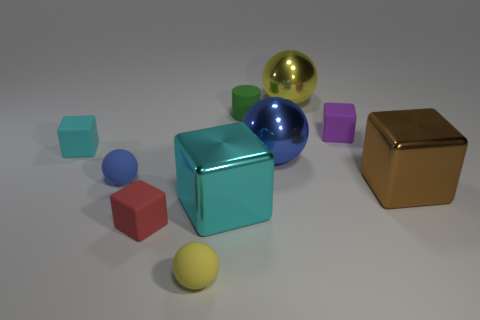Subtract all big cyan cubes. How many cubes are left? 4 Subtract 2 spheres. How many spheres are left? 2 Subtract all cyan blocks. How many blocks are left? 3 Subtract all cyan balls. Subtract all yellow cylinders. How many balls are left? 4 Subtract all blue cylinders. How many green spheres are left? 0 Subtract all big yellow metallic things. Subtract all large cyan metallic cubes. How many objects are left? 8 Add 4 tiny rubber things. How many tiny rubber things are left? 10 Add 4 tiny yellow spheres. How many tiny yellow spheres exist? 5 Subtract 1 purple cubes. How many objects are left? 9 Subtract all spheres. How many objects are left? 6 